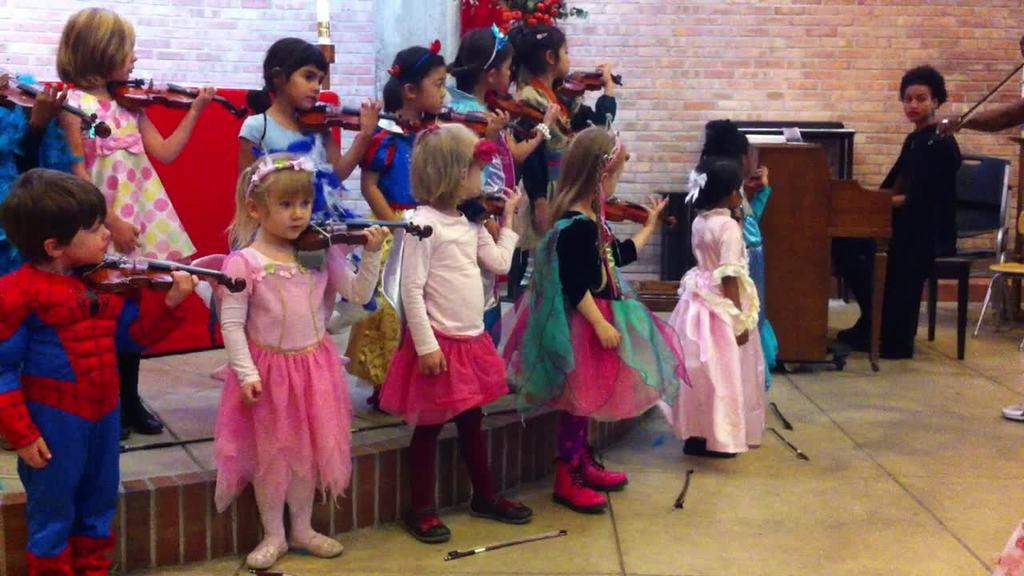How many people are in the image? There are children and a woman in the image, so there are at least three people. What are the people in the image doing? Everyone in the image is holding a musical instrument. Can you describe the woman in the image? The woman is in the image along with the children, and she is also holding a musical instrument. What type of yarn is the woman using to play her musical instrument in the image? There is no yarn present in the image, and the musical instruments do not require yarn to be played. 